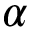Convert formula to latex. <formula><loc_0><loc_0><loc_500><loc_500>\alpha</formula> 